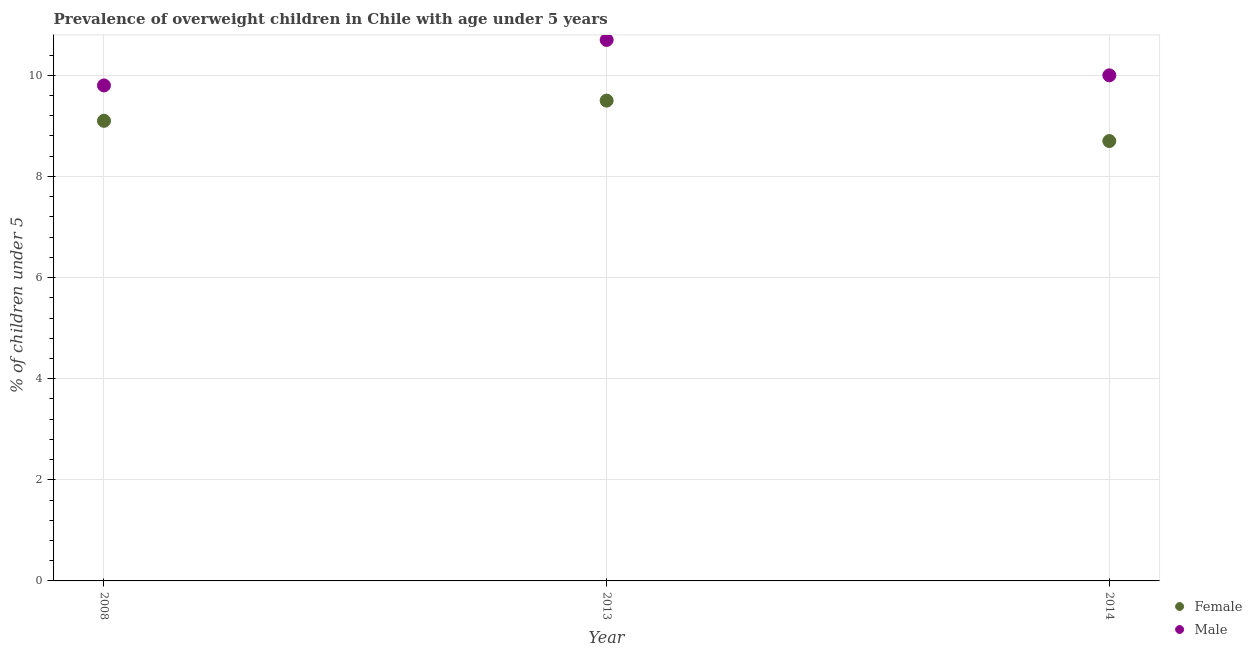Is the number of dotlines equal to the number of legend labels?
Ensure brevity in your answer.  Yes. What is the percentage of obese male children in 2008?
Keep it short and to the point. 9.8. Across all years, what is the maximum percentage of obese male children?
Ensure brevity in your answer.  10.7. Across all years, what is the minimum percentage of obese male children?
Ensure brevity in your answer.  9.8. In which year was the percentage of obese male children maximum?
Your response must be concise. 2013. What is the total percentage of obese female children in the graph?
Provide a short and direct response. 27.3. What is the difference between the percentage of obese male children in 2013 and that in 2014?
Give a very brief answer. 0.7. What is the difference between the percentage of obese male children in 2013 and the percentage of obese female children in 2008?
Make the answer very short. 1.6. What is the average percentage of obese male children per year?
Provide a short and direct response. 10.17. In the year 2008, what is the difference between the percentage of obese female children and percentage of obese male children?
Make the answer very short. -0.7. What is the ratio of the percentage of obese female children in 2008 to that in 2014?
Offer a terse response. 1.05. Is the percentage of obese male children in 2008 less than that in 2013?
Your answer should be compact. Yes. What is the difference between the highest and the second highest percentage of obese male children?
Your answer should be compact. 0.7. What is the difference between the highest and the lowest percentage of obese male children?
Provide a short and direct response. 0.9. In how many years, is the percentage of obese female children greater than the average percentage of obese female children taken over all years?
Give a very brief answer. 2. How many dotlines are there?
Ensure brevity in your answer.  2. How many years are there in the graph?
Your response must be concise. 3. What is the difference between two consecutive major ticks on the Y-axis?
Offer a very short reply. 2. Does the graph contain any zero values?
Make the answer very short. No. Where does the legend appear in the graph?
Provide a succinct answer. Bottom right. How many legend labels are there?
Give a very brief answer. 2. How are the legend labels stacked?
Make the answer very short. Vertical. What is the title of the graph?
Keep it short and to the point. Prevalence of overweight children in Chile with age under 5 years. What is the label or title of the Y-axis?
Make the answer very short.  % of children under 5. What is the  % of children under 5 of Female in 2008?
Ensure brevity in your answer.  9.1. What is the  % of children under 5 in Male in 2008?
Provide a short and direct response. 9.8. What is the  % of children under 5 of Female in 2013?
Your response must be concise. 9.5. What is the  % of children under 5 in Male in 2013?
Keep it short and to the point. 10.7. What is the  % of children under 5 of Female in 2014?
Make the answer very short. 8.7. Across all years, what is the maximum  % of children under 5 in Female?
Provide a succinct answer. 9.5. Across all years, what is the maximum  % of children under 5 of Male?
Offer a very short reply. 10.7. Across all years, what is the minimum  % of children under 5 in Female?
Provide a succinct answer. 8.7. Across all years, what is the minimum  % of children under 5 of Male?
Make the answer very short. 9.8. What is the total  % of children under 5 in Female in the graph?
Offer a very short reply. 27.3. What is the total  % of children under 5 in Male in the graph?
Ensure brevity in your answer.  30.5. What is the difference between the  % of children under 5 of Female in 2008 and that in 2014?
Keep it short and to the point. 0.4. What is the difference between the  % of children under 5 of Female in 2008 and the  % of children under 5 of Male in 2013?
Give a very brief answer. -1.6. What is the average  % of children under 5 of Female per year?
Give a very brief answer. 9.1. What is the average  % of children under 5 in Male per year?
Make the answer very short. 10.17. In the year 2008, what is the difference between the  % of children under 5 in Female and  % of children under 5 in Male?
Your answer should be very brief. -0.7. What is the ratio of the  % of children under 5 of Female in 2008 to that in 2013?
Provide a short and direct response. 0.96. What is the ratio of the  % of children under 5 of Male in 2008 to that in 2013?
Your response must be concise. 0.92. What is the ratio of the  % of children under 5 in Female in 2008 to that in 2014?
Keep it short and to the point. 1.05. What is the ratio of the  % of children under 5 of Female in 2013 to that in 2014?
Give a very brief answer. 1.09. What is the ratio of the  % of children under 5 of Male in 2013 to that in 2014?
Give a very brief answer. 1.07. What is the difference between the highest and the second highest  % of children under 5 of Male?
Your answer should be very brief. 0.7. What is the difference between the highest and the lowest  % of children under 5 of Male?
Provide a succinct answer. 0.9. 